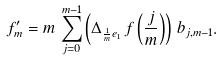Convert formula to latex. <formula><loc_0><loc_0><loc_500><loc_500>f _ { m } ^ { \prime } = m \, \sum _ { j = 0 } ^ { m - 1 } \left ( \Delta _ { \frac { 1 } { m } e _ { 1 } } \, f \left ( \frac { j } { m } \right ) \right ) \, b _ { j , m - 1 } .</formula> 